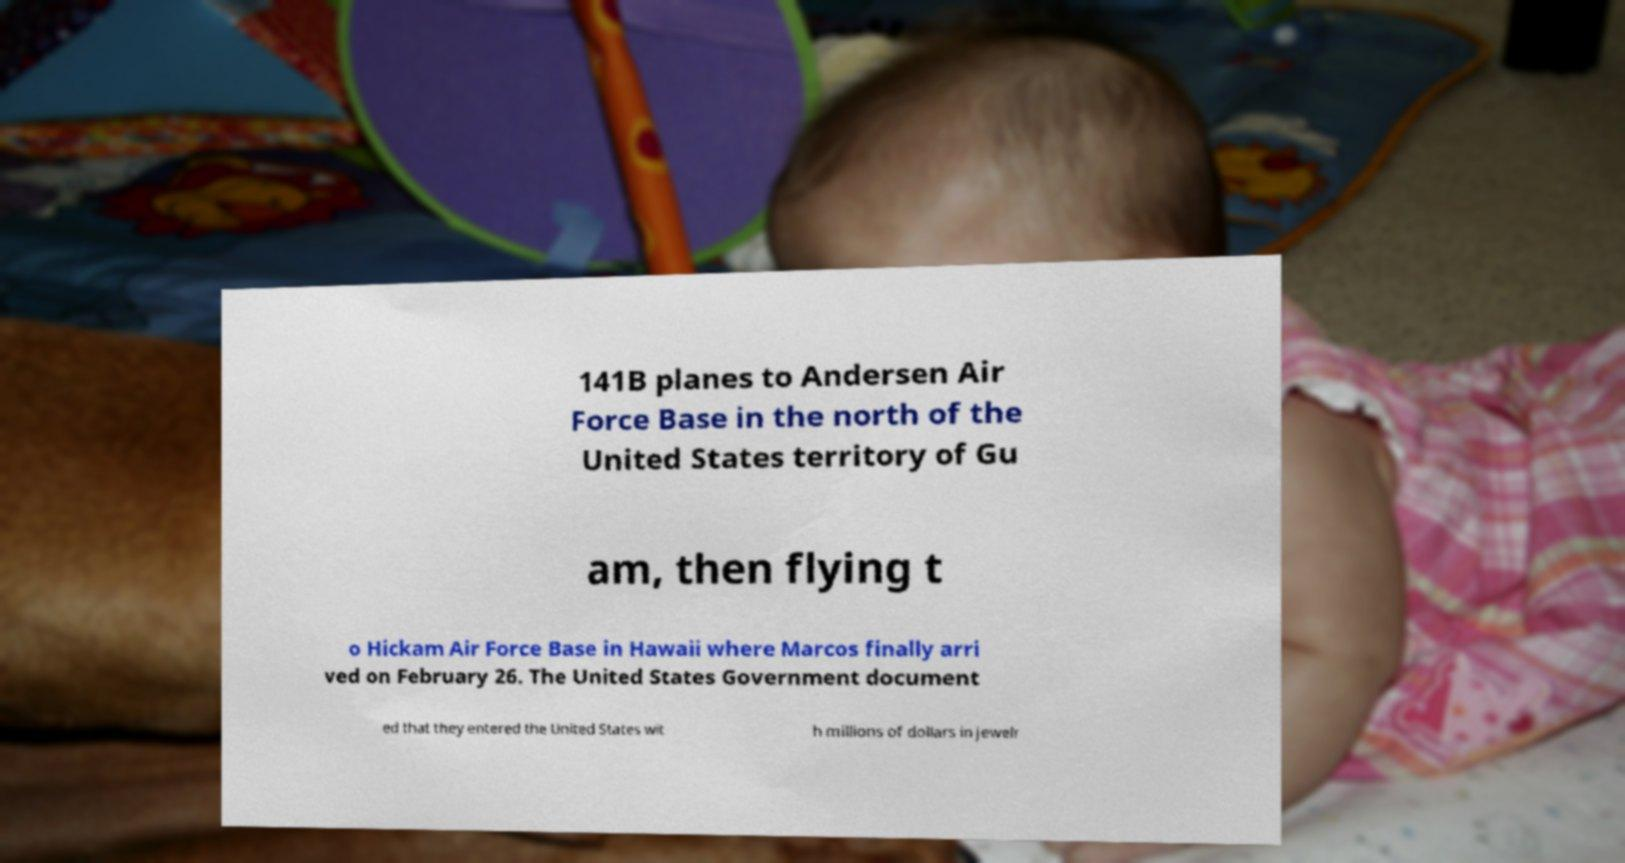For documentation purposes, I need the text within this image transcribed. Could you provide that? 141B planes to Andersen Air Force Base in the north of the United States territory of Gu am, then flying t o Hickam Air Force Base in Hawaii where Marcos finally arri ved on February 26. The United States Government document ed that they entered the United States wit h millions of dollars in jewelr 